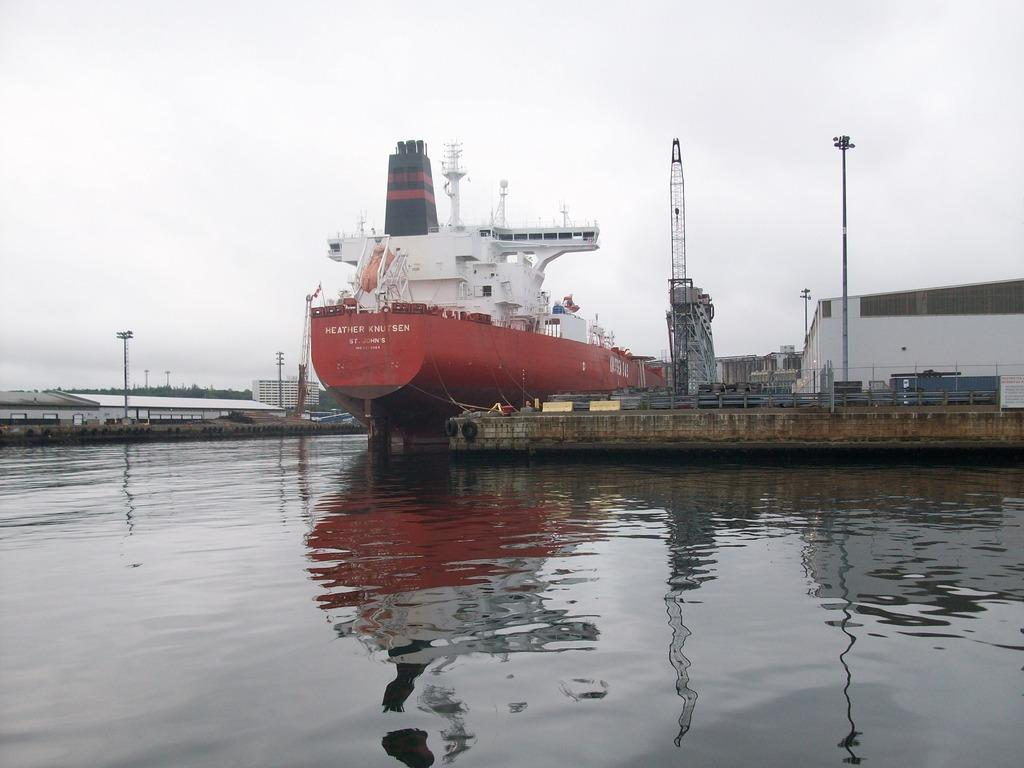Provide a one-sentence caption for the provided image. The ship Heather Knutsen sits at the dock on a gray day. 